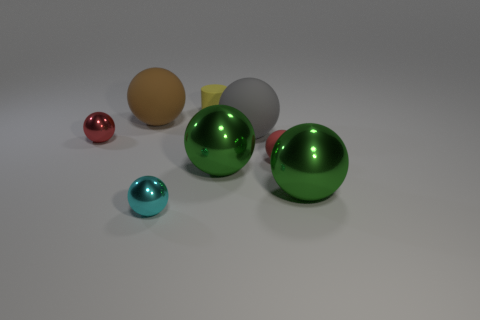Can you describe the smallest sphere's appearance and what it might be made of? The smallest sphere has a smooth, shiny surface with a deep red color, which gives it a look similar to a polished gemstone or colored glass. This reflective characteristic indicates that the material could potentially be a reflective glass or a polished semi-precious stone with a glossy finish. 